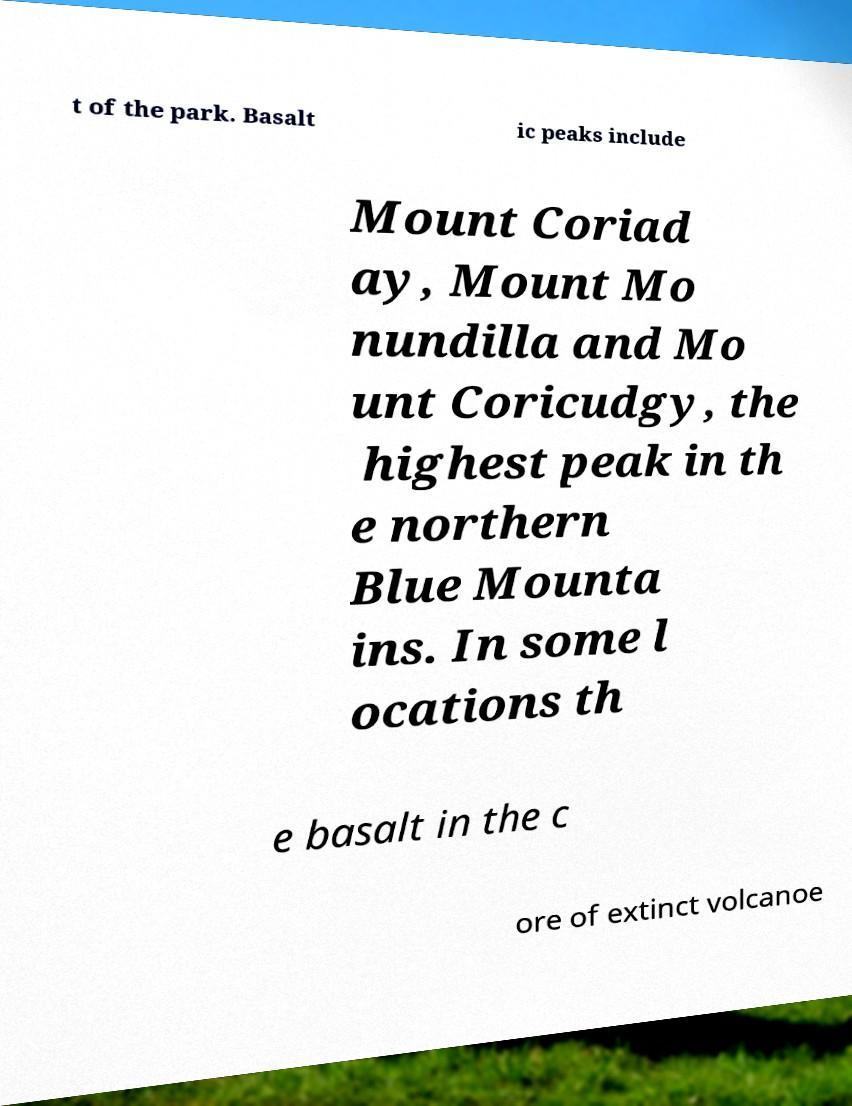What messages or text are displayed in this image? I need them in a readable, typed format. t of the park. Basalt ic peaks include Mount Coriad ay, Mount Mo nundilla and Mo unt Coricudgy, the highest peak in th e northern Blue Mounta ins. In some l ocations th e basalt in the c ore of extinct volcanoe 